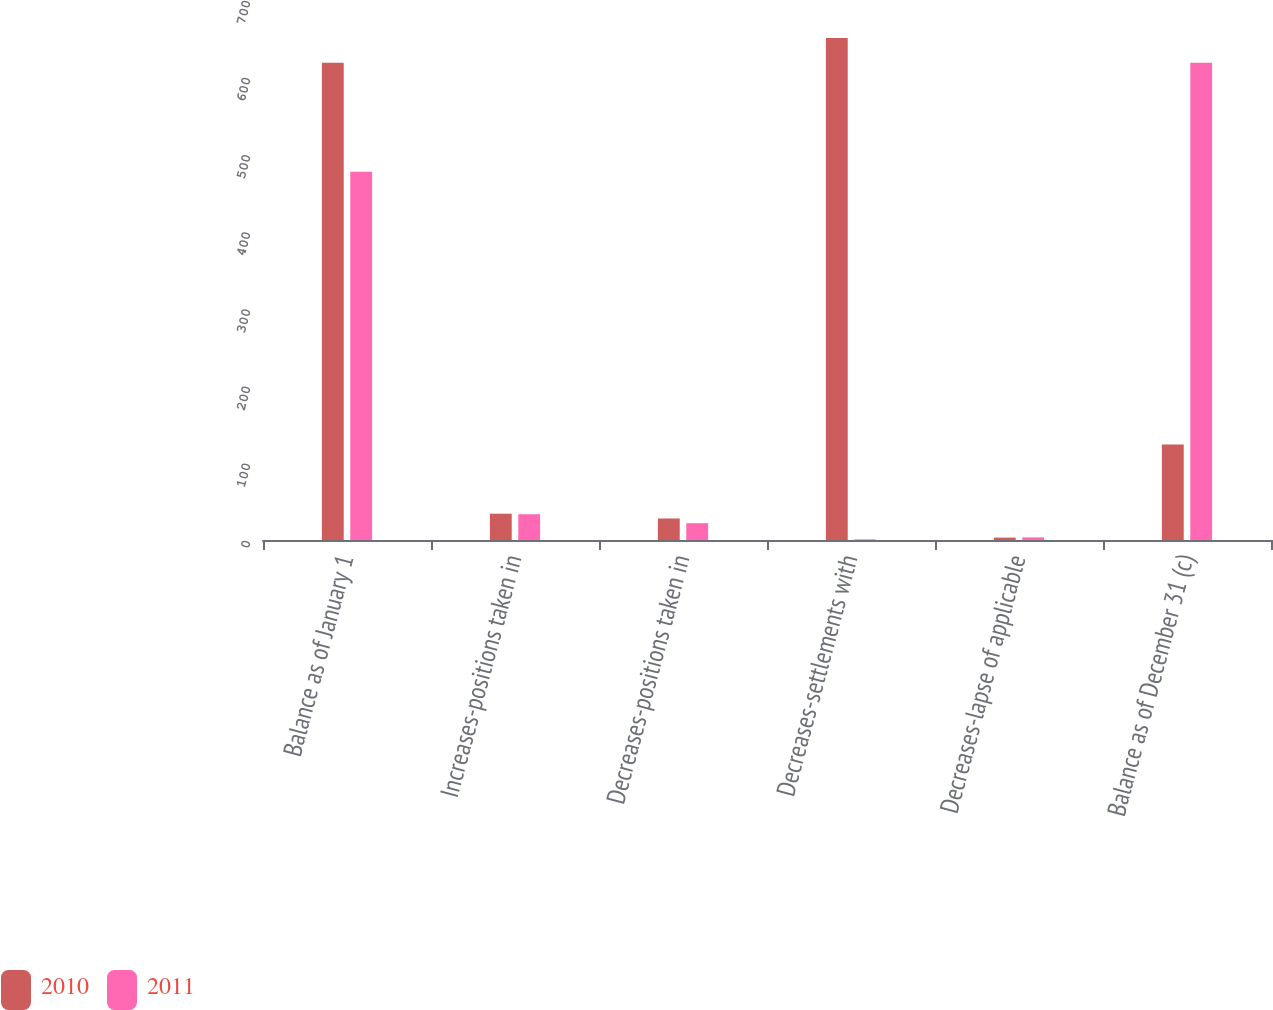<chart> <loc_0><loc_0><loc_500><loc_500><stacked_bar_chart><ecel><fcel>Balance as of January 1<fcel>Increases-positions taken in<fcel>Decreases-positions taken in<fcel>Decreases-settlements with<fcel>Decreases-lapse of applicable<fcel>Balance as of December 31 (c)<nl><fcel>2010<fcel>618.7<fcel>34.1<fcel>27.9<fcel>650.9<fcel>3.1<fcel>123.7<nl><fcel>2011<fcel>477.2<fcel>33.4<fcel>21.8<fcel>0.8<fcel>3.4<fcel>618.7<nl></chart> 